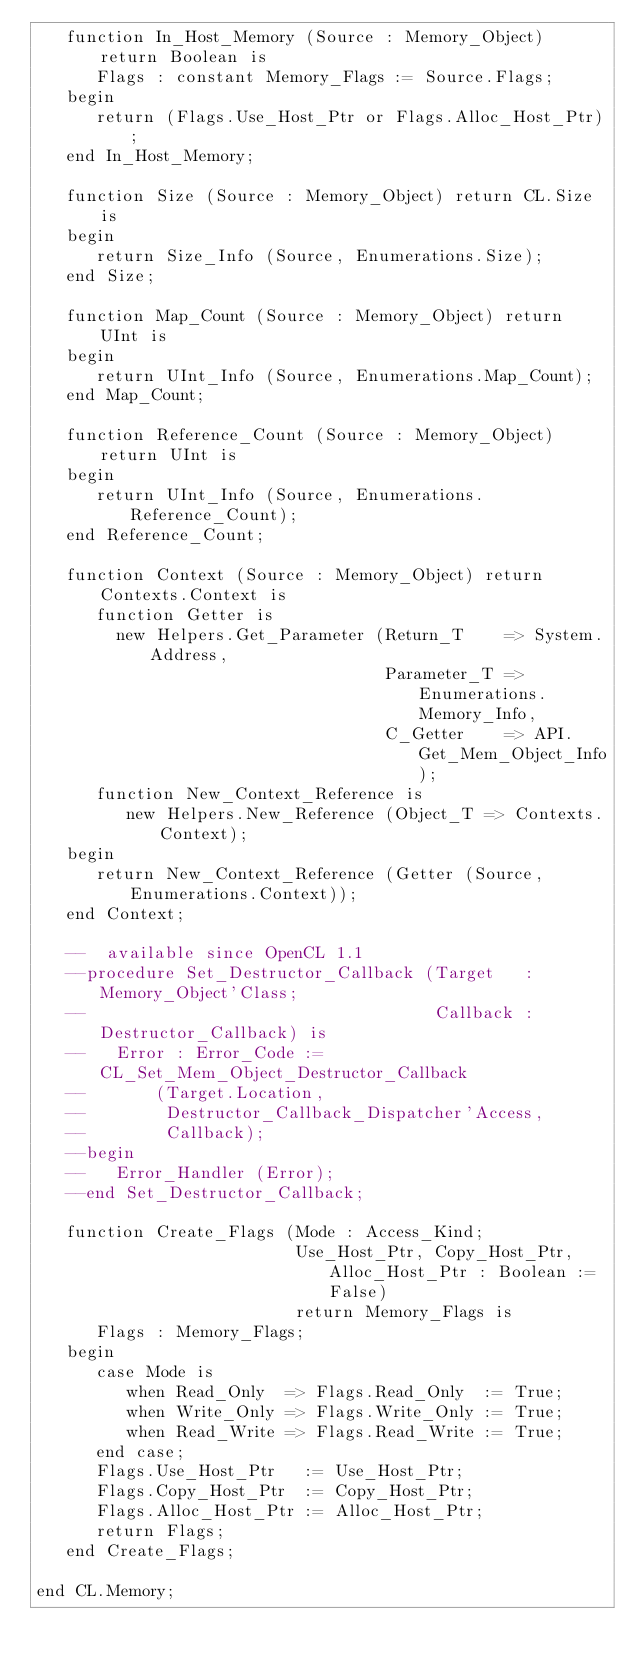<code> <loc_0><loc_0><loc_500><loc_500><_Ada_>   function In_Host_Memory (Source : Memory_Object) return Boolean is
      Flags : constant Memory_Flags := Source.Flags;
   begin
      return (Flags.Use_Host_Ptr or Flags.Alloc_Host_Ptr);
   end In_Host_Memory;

   function Size (Source : Memory_Object) return CL.Size is
   begin
      return Size_Info (Source, Enumerations.Size);
   end Size;

   function Map_Count (Source : Memory_Object) return UInt is
   begin
      return UInt_Info (Source, Enumerations.Map_Count);
   end Map_Count;

   function Reference_Count (Source : Memory_Object) return UInt is
   begin
      return UInt_Info (Source, Enumerations.Reference_Count);
   end Reference_Count;

   function Context (Source : Memory_Object) return Contexts.Context is
      function Getter is
        new Helpers.Get_Parameter (Return_T    => System.Address,
                                   Parameter_T => Enumerations.Memory_Info,
                                   C_Getter    => API.Get_Mem_Object_Info);
      function New_Context_Reference is
         new Helpers.New_Reference (Object_T => Contexts.Context);
   begin
      return New_Context_Reference (Getter (Source, Enumerations.Context));
   end Context;

   --  available since OpenCL 1.1
   --procedure Set_Destructor_Callback (Target   : Memory_Object'Class;
   --                                   Callback : Destructor_Callback) is
   --   Error : Error_Code := CL_Set_Mem_Object_Destructor_Callback
   --       (Target.Location,
   --        Destructor_Callback_Dispatcher'Access,
   --        Callback);
   --begin
   --   Error_Handler (Error);
   --end Set_Destructor_Callback;

   function Create_Flags (Mode : Access_Kind;
                          Use_Host_Ptr, Copy_Host_Ptr, Alloc_Host_Ptr : Boolean := False)
                          return Memory_Flags is
      Flags : Memory_Flags;
   begin
      case Mode is
         when Read_Only  => Flags.Read_Only  := True;
         when Write_Only => Flags.Write_Only := True;
         when Read_Write => Flags.Read_Write := True;
      end case;
      Flags.Use_Host_Ptr   := Use_Host_Ptr;
      Flags.Copy_Host_Ptr  := Copy_Host_Ptr;
      Flags.Alloc_Host_Ptr := Alloc_Host_Ptr;
      return Flags;
   end Create_Flags;

end CL.Memory;
</code> 